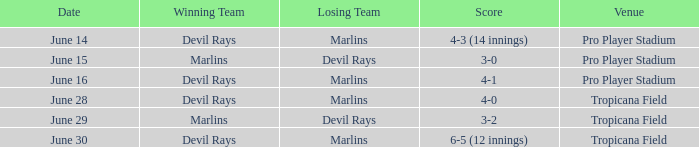What was the tally on june 29 when the devil rays were defeated? 3-2. Could you help me parse every detail presented in this table? {'header': ['Date', 'Winning Team', 'Losing Team', 'Score', 'Venue'], 'rows': [['June 14', 'Devil Rays', 'Marlins', '4-3 (14 innings)', 'Pro Player Stadium'], ['June 15', 'Marlins', 'Devil Rays', '3-0', 'Pro Player Stadium'], ['June 16', 'Devil Rays', 'Marlins', '4-1', 'Pro Player Stadium'], ['June 28', 'Devil Rays', 'Marlins', '4-0', 'Tropicana Field'], ['June 29', 'Marlins', 'Devil Rays', '3-2', 'Tropicana Field'], ['June 30', 'Devil Rays', 'Marlins', '6-5 (12 innings)', 'Tropicana Field']]} 